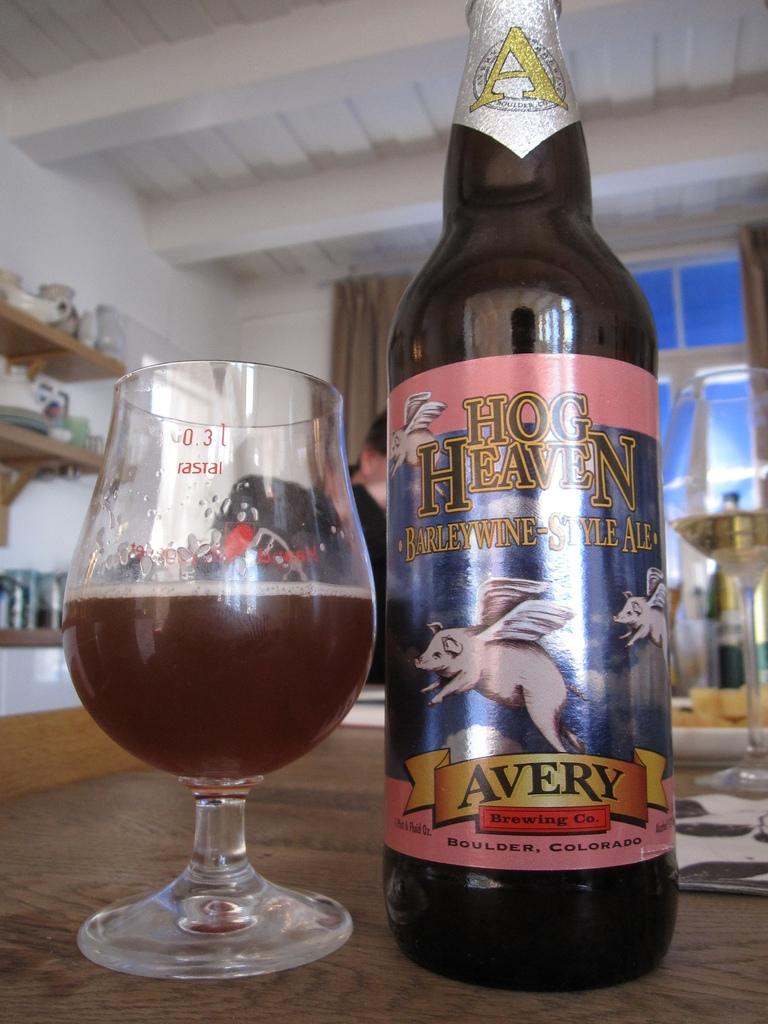<image>
Describe the image concisely. A bottle of Avery Hog Heaven Barleywine Style Ale sits next to a half full tasting glass. 